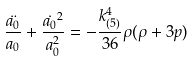<formula> <loc_0><loc_0><loc_500><loc_500>\frac { \ddot { a _ { 0 } } } { a _ { 0 } } + \frac { \dot { a _ { 0 } } ^ { 2 } } { a _ { 0 } ^ { 2 } } = - \frac { k ^ { 4 } _ { ( 5 ) } } { 3 6 } \rho ( \rho + 3 p )</formula> 